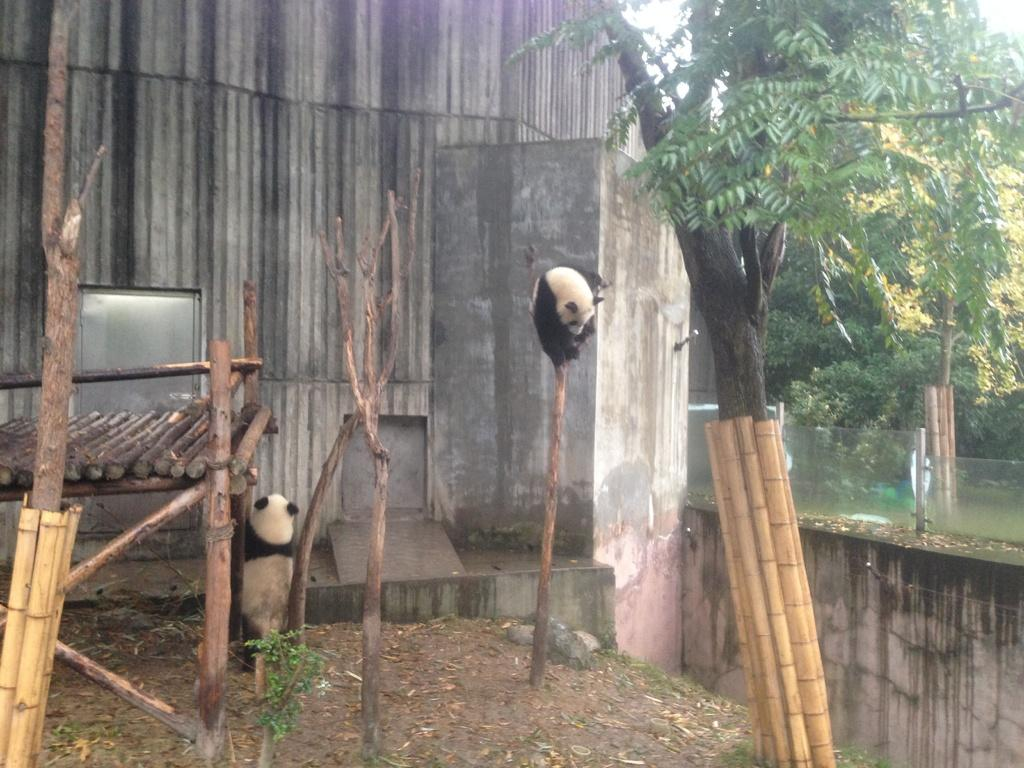What type of animals are in the image? There are pandas in the image. What can be seen in the background of the image? There are trees in the image. What grade is the person teaching in the image? There is no person present in the image, let alone someone teaching a class. 